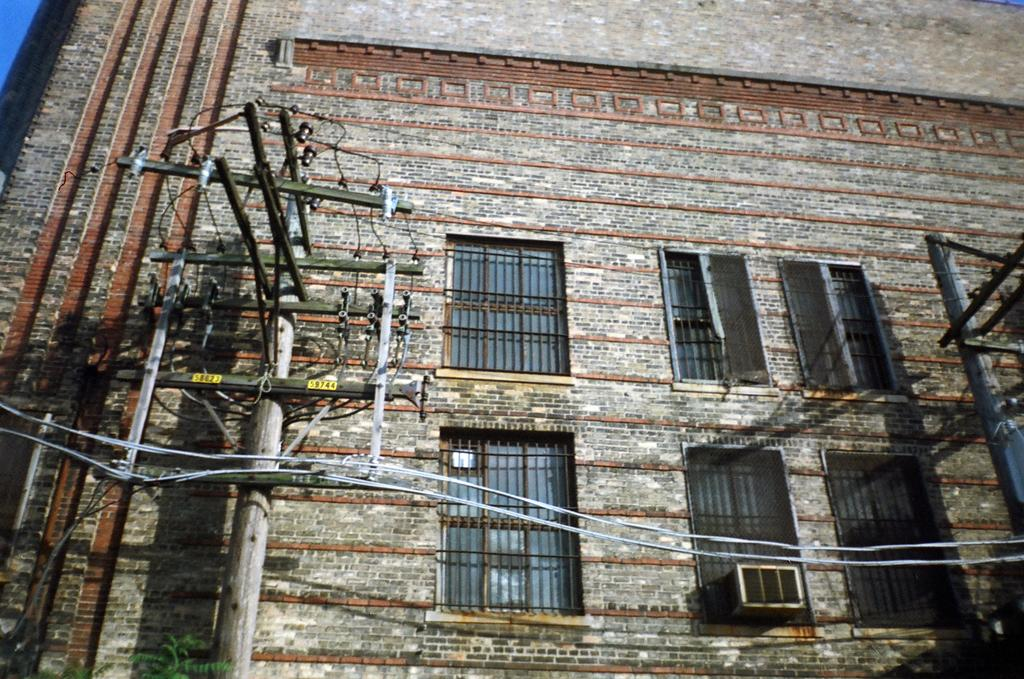What type of structures are present in the image? There are current poles and a brick building in the image. What can be seen connecting the current poles? There are wires in the image connecting the current poles. What is attached to the brick building? There is an air conditioner fan attached to the brick building. What type of openings can be seen in the brick building? There are windows in the image. What type of record is being played by the farmer in the image? There is no farmer or record present in the image. How does the slip affect the current poles in the image? There is no slip present in the image, so it cannot affect the current poles. 